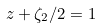Convert formula to latex. <formula><loc_0><loc_0><loc_500><loc_500>z + \zeta _ { 2 } / 2 = 1</formula> 